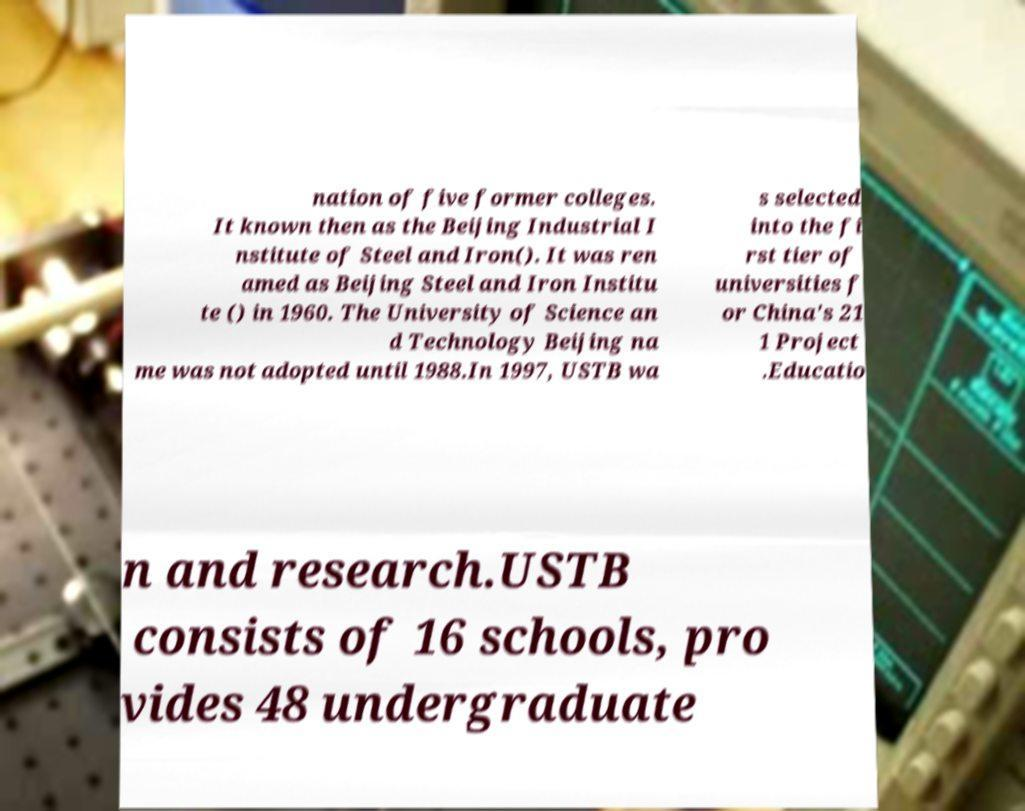I need the written content from this picture converted into text. Can you do that? nation of five former colleges. It known then as the Beijing Industrial I nstitute of Steel and Iron(). It was ren amed as Beijing Steel and Iron Institu te () in 1960. The University of Science an d Technology Beijing na me was not adopted until 1988.In 1997, USTB wa s selected into the fi rst tier of universities f or China's 21 1 Project .Educatio n and research.USTB consists of 16 schools, pro vides 48 undergraduate 